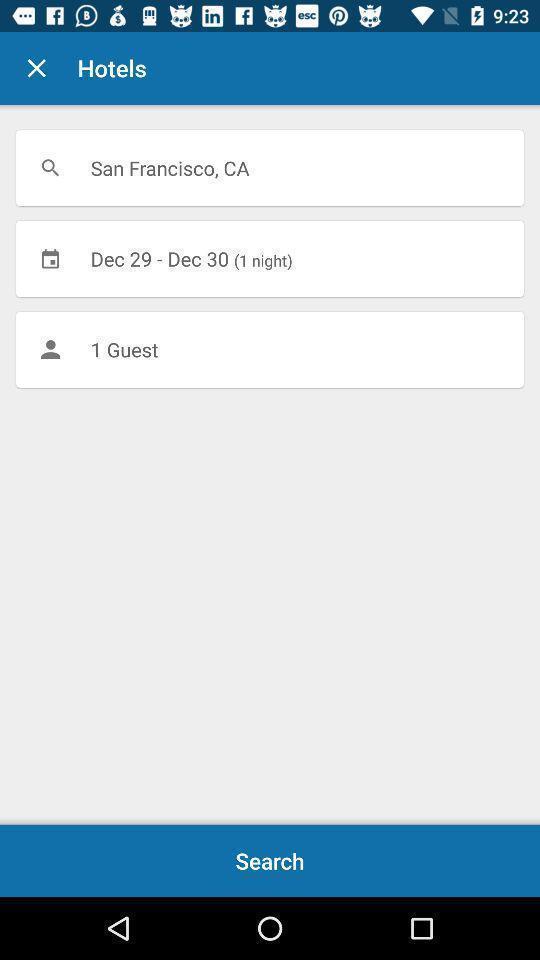Provide a description of this screenshot. Screen shows a search of hotels. 